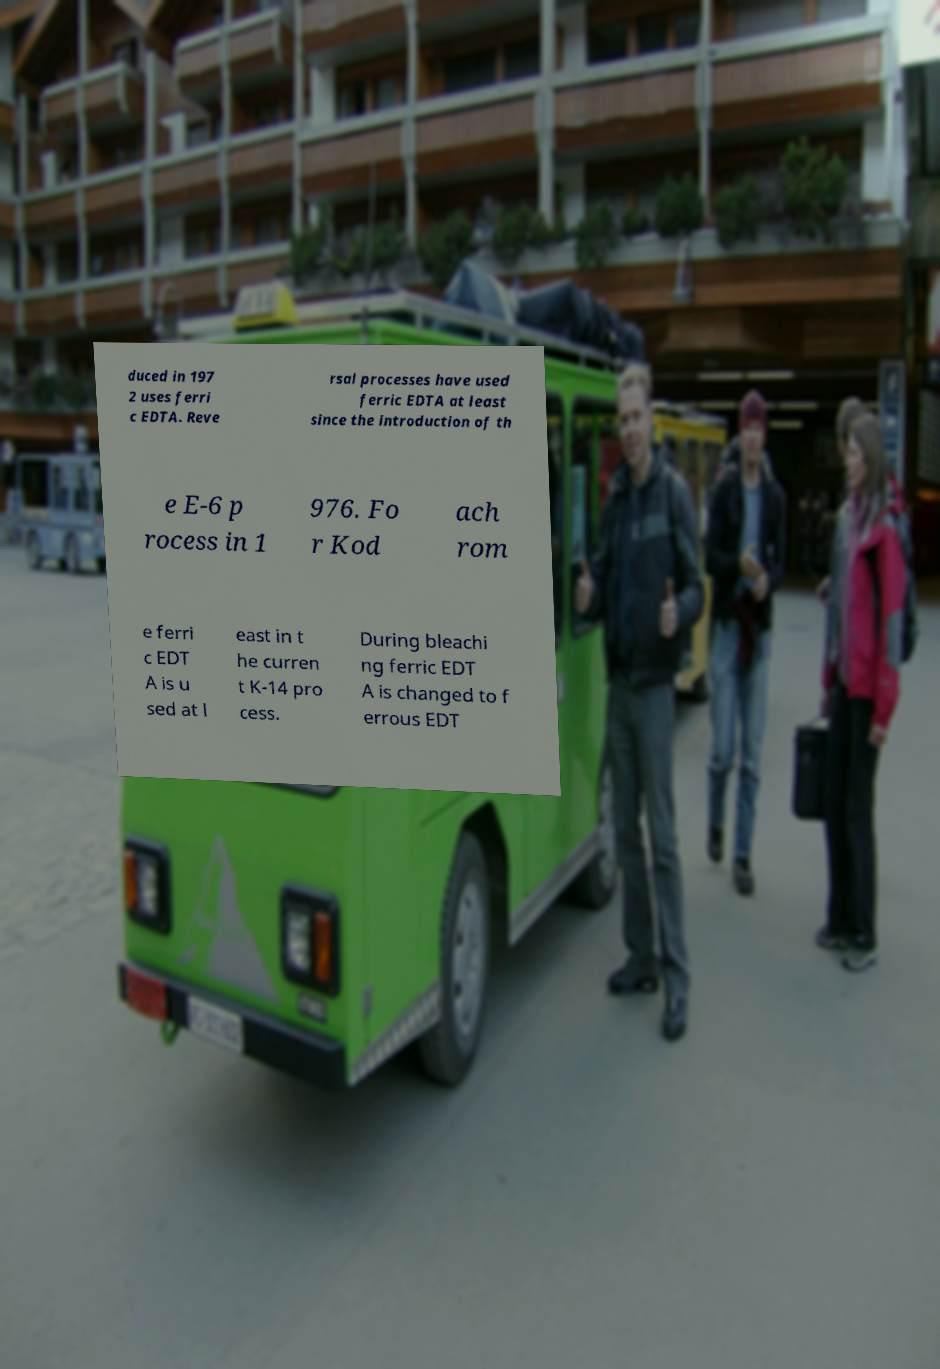Please identify and transcribe the text found in this image. duced in 197 2 uses ferri c EDTA. Reve rsal processes have used ferric EDTA at least since the introduction of th e E-6 p rocess in 1 976. Fo r Kod ach rom e ferri c EDT A is u sed at l east in t he curren t K-14 pro cess. During bleachi ng ferric EDT A is changed to f errous EDT 